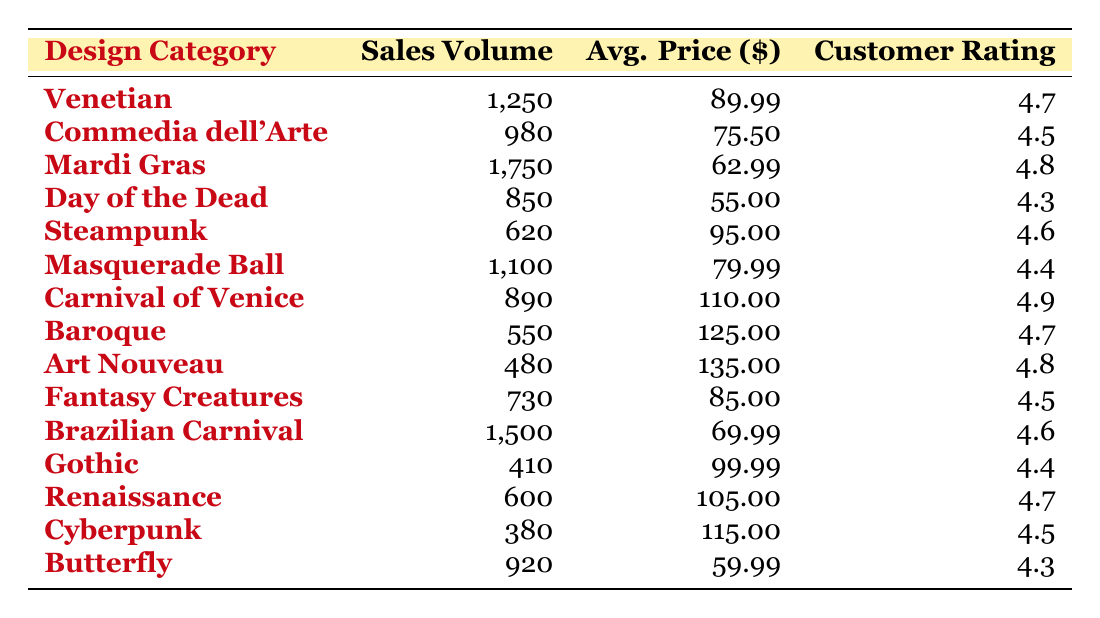What is the highest sales volume among all design categories? The "Mardi Gras" design category has the highest sales volume of 1,750, which can be found in the second row of the table.
Answer: 1,750 Which design category has the highest average price? The "Art Nouveau" design category has the highest average price of $135.00, which can be found in the third column of the row for that design.
Answer: $135.00 How many more masks were sold in the Brazilian Carnival category compared to the Gothic category? The Brazilian Carnival category sold 1,500 masks, and the Gothic category sold 410 masks. The difference is 1,500 - 410 = 1,090.
Answer: 1,090 What is the average customer rating of all design categories? To find the average customer rating, we sum all the ratings: (4.7 + 4.5 + 4.8 + 4.3 + 4.6 + 4.4 + 4.9 + 4.7 + 4.8 + 4.5 + 4.6 + 4.4 + 4.7 + 4.5 + 4.3) = 67.5, and then divide by the number of categories, which is 15. So the average rating is 67.5 / 15 = 4.5.
Answer: 4.5 Is the customer rating of the "Day of the Dead" design higher than the "Steampunk" design? The customer rating for "Day of the Dead" is 4.3, and for "Steampunk," it is 4.6. Since 4.3 is less than 4.6, the statement is false.
Answer: No Which design categories had sales volumes below 800? The design categories with sales volumes below 800 are "Day of the Dead" (850), "Baroque" (550), "Art Nouveau" (480), "Gothic" (410), and "Cyberpunk" (380).
Answer: Day of the Dead, Baroque, Art Nouveau, Gothic, Cyberpunk What is the total sales volume of all categories combined? To find total sales volume, we add all sales volumes: 1250 + 980 + 1750 + 850 + 620 + 1100 + 890 + 550 + 480 + 730 + 1500 + 410 + 600 + 380 + 920 = 13,750.
Answer: 13,750 Which design categories have a customer rating of 4.6 or higher and sold more than 1,000 masks? The design categories that meet these conditions are "Mardi Gras" (1,750, rating 4.8) and "Brazilian Carnival" (1,500, rating 4.6).
Answer: Mardi Gras, Brazilian Carnival What is the relationship between the average price and customer rating for "Commedia dell'Arte" and "Carnival of Venice"? "Commedia dell'Arte" has an average price of $75.50 and a customer rating of 4.5. "Carnival of Venice" has a higher average price of $110.00 and a customer rating of 4.9. The relationship shows that a higher price does not necessarily lower the customer rating in this case.
Answer: Higher price corresponds to higher rating for Carnival of Venice 